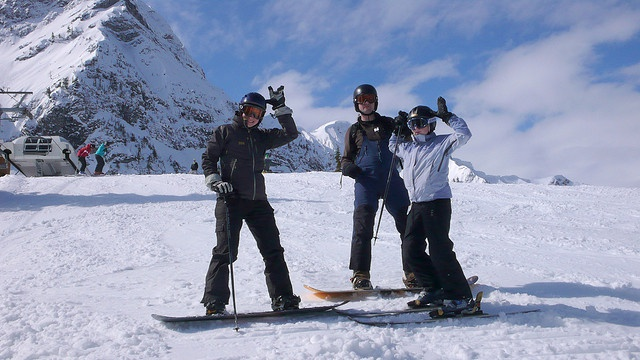Describe the objects in this image and their specific colors. I can see people in lavender, black, and gray tones, people in lavender, black, gray, and darkgray tones, people in lavender, black, navy, and gray tones, snowboard in lavender, black, and gray tones, and skis in lavender, gray, and black tones in this image. 